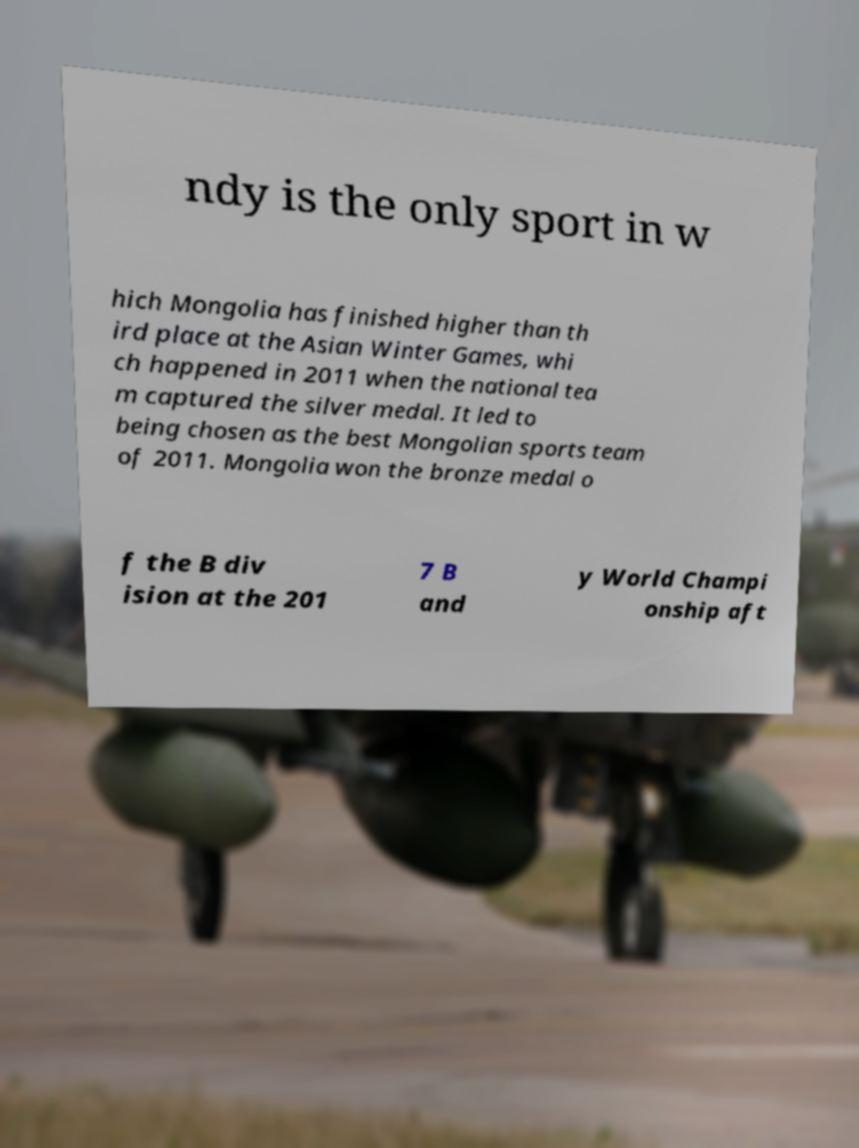Could you extract and type out the text from this image? ndy is the only sport in w hich Mongolia has finished higher than th ird place at the Asian Winter Games, whi ch happened in 2011 when the national tea m captured the silver medal. It led to being chosen as the best Mongolian sports team of 2011. Mongolia won the bronze medal o f the B div ision at the 201 7 B and y World Champi onship aft 